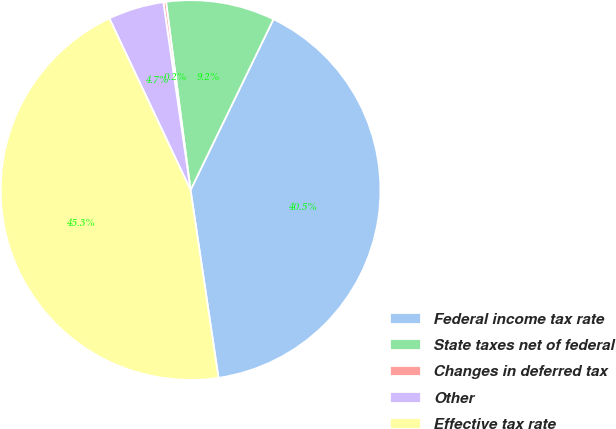<chart> <loc_0><loc_0><loc_500><loc_500><pie_chart><fcel>Federal income tax rate<fcel>State taxes net of federal<fcel>Changes in deferred tax<fcel>Other<fcel>Effective tax rate<nl><fcel>40.46%<fcel>9.25%<fcel>0.23%<fcel>4.74%<fcel>45.32%<nl></chart> 